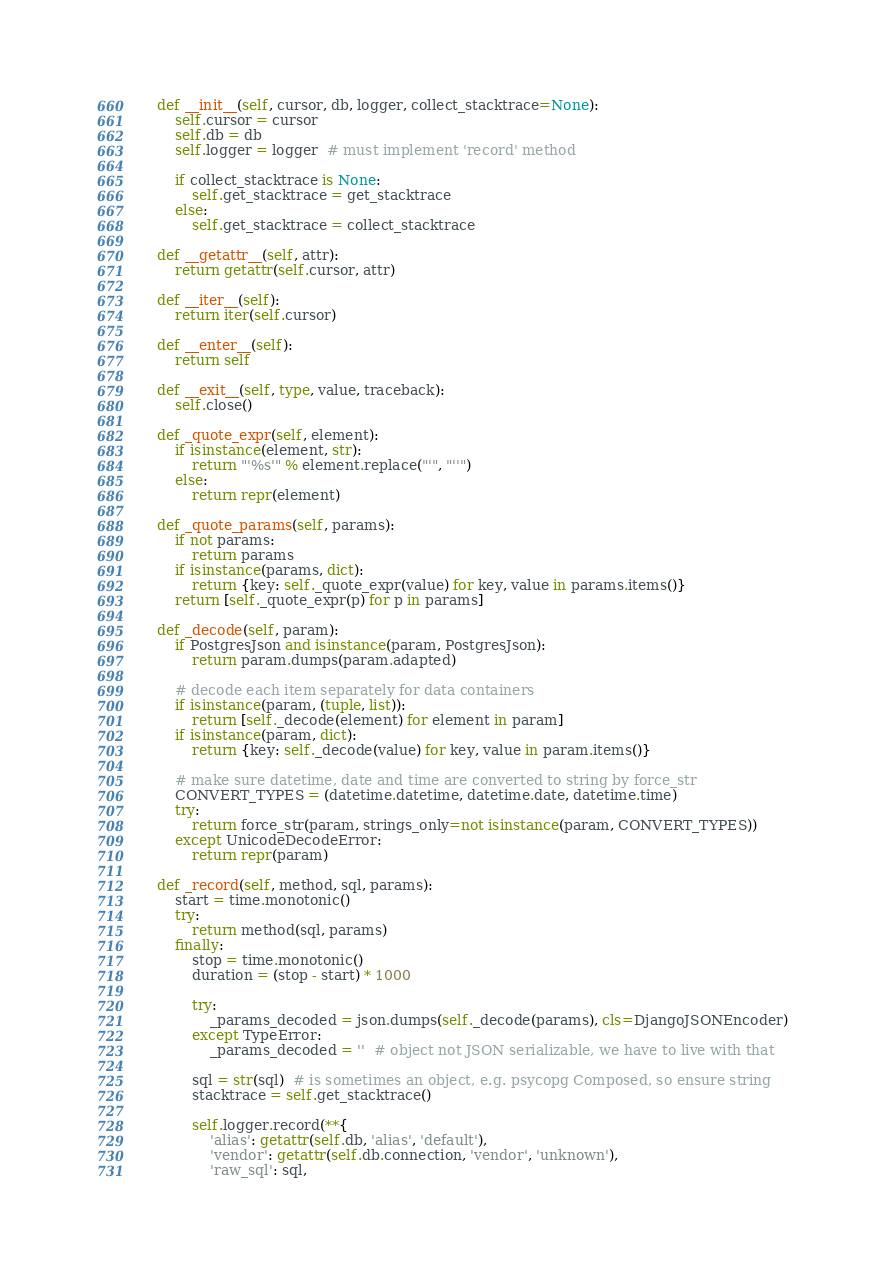<code> <loc_0><loc_0><loc_500><loc_500><_Python_>
    def __init__(self, cursor, db, logger, collect_stacktrace=None):
        self.cursor = cursor
        self.db = db
        self.logger = logger  # must implement 'record' method

        if collect_stacktrace is None:
            self.get_stacktrace = get_stacktrace
        else:
            self.get_stacktrace = collect_stacktrace

    def __getattr__(self, attr):
        return getattr(self.cursor, attr)

    def __iter__(self):
        return iter(self.cursor)

    def __enter__(self):
        return self

    def __exit__(self, type, value, traceback):
        self.close()

    def _quote_expr(self, element):
        if isinstance(element, str):
            return "'%s'" % element.replace("'", "''")
        else:
            return repr(element)

    def _quote_params(self, params):
        if not params:
            return params
        if isinstance(params, dict):
            return {key: self._quote_expr(value) for key, value in params.items()}
        return [self._quote_expr(p) for p in params]

    def _decode(self, param):
        if PostgresJson and isinstance(param, PostgresJson):
            return param.dumps(param.adapted)

        # decode each item separately for data containers
        if isinstance(param, (tuple, list)):
            return [self._decode(element) for element in param]
        if isinstance(param, dict):
            return {key: self._decode(value) for key, value in param.items()}

        # make sure datetime, date and time are converted to string by force_str
        CONVERT_TYPES = (datetime.datetime, datetime.date, datetime.time)
        try:
            return force_str(param, strings_only=not isinstance(param, CONVERT_TYPES))
        except UnicodeDecodeError:
            return repr(param)

    def _record(self, method, sql, params):
        start = time.monotonic()
        try:
            return method(sql, params)
        finally:
            stop = time.monotonic()
            duration = (stop - start) * 1000

            try:
                _params_decoded = json.dumps(self._decode(params), cls=DjangoJSONEncoder)
            except TypeError:
                _params_decoded = ''  # object not JSON serializable, we have to live with that

            sql = str(sql)  # is sometimes an object, e.g. psycopg Composed, so ensure string
            stacktrace = self.get_stacktrace()

            self.logger.record(**{
                'alias': getattr(self.db, 'alias', 'default'),
                'vendor': getattr(self.db.connection, 'vendor', 'unknown'),
                'raw_sql': sql,</code> 